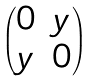<formula> <loc_0><loc_0><loc_500><loc_500>\begin{pmatrix} 0 & y \\ y & 0 \end{pmatrix}</formula> 